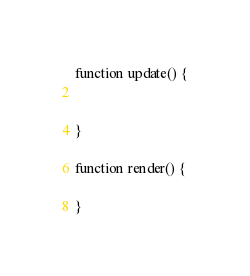Convert code to text. <code><loc_0><loc_0><loc_500><loc_500><_JavaScript_>
function update() {


}

function render() {

}
</code> 